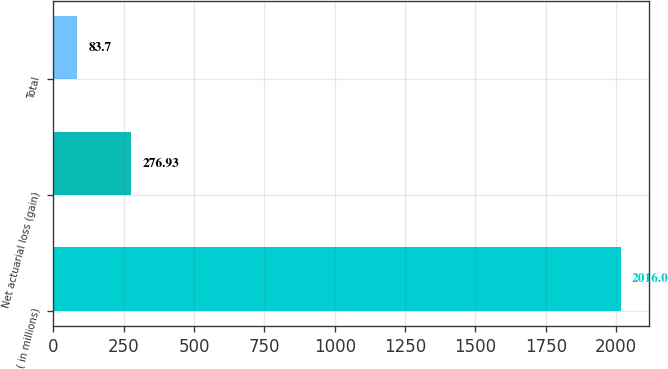<chart> <loc_0><loc_0><loc_500><loc_500><bar_chart><fcel>( in millions)<fcel>Net actuarial loss (gain)<fcel>Total<nl><fcel>2016<fcel>276.93<fcel>83.7<nl></chart> 